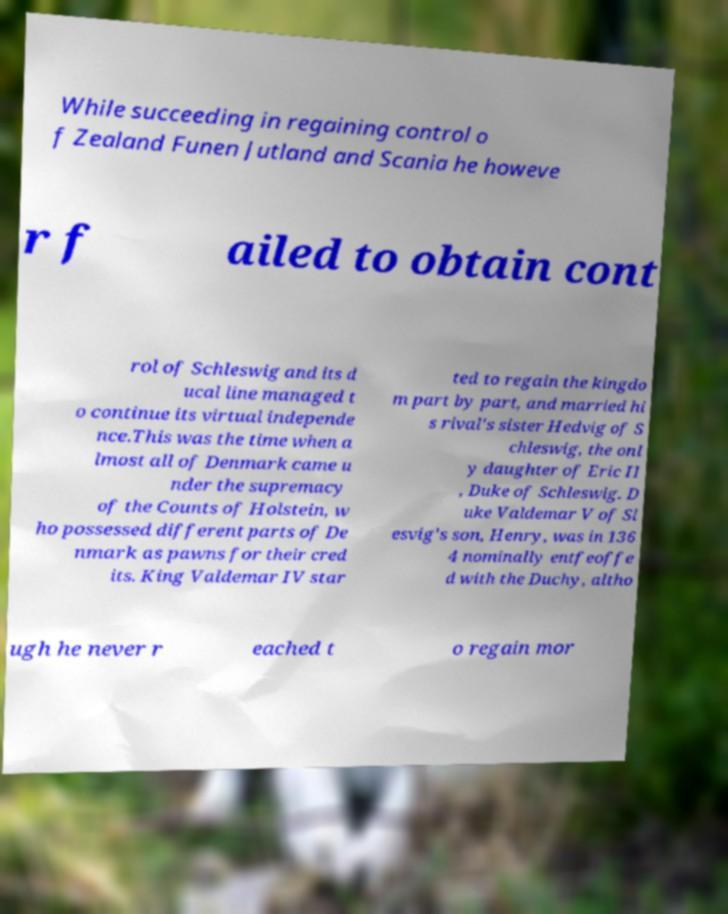Could you assist in decoding the text presented in this image and type it out clearly? While succeeding in regaining control o f Zealand Funen Jutland and Scania he howeve r f ailed to obtain cont rol of Schleswig and its d ucal line managed t o continue its virtual independe nce.This was the time when a lmost all of Denmark came u nder the supremacy of the Counts of Holstein, w ho possessed different parts of De nmark as pawns for their cred its. King Valdemar IV star ted to regain the kingdo m part by part, and married hi s rival's sister Hedvig of S chleswig, the onl y daughter of Eric II , Duke of Schleswig. D uke Valdemar V of Sl esvig's son, Henry, was in 136 4 nominally entfeoffe d with the Duchy, altho ugh he never r eached t o regain mor 